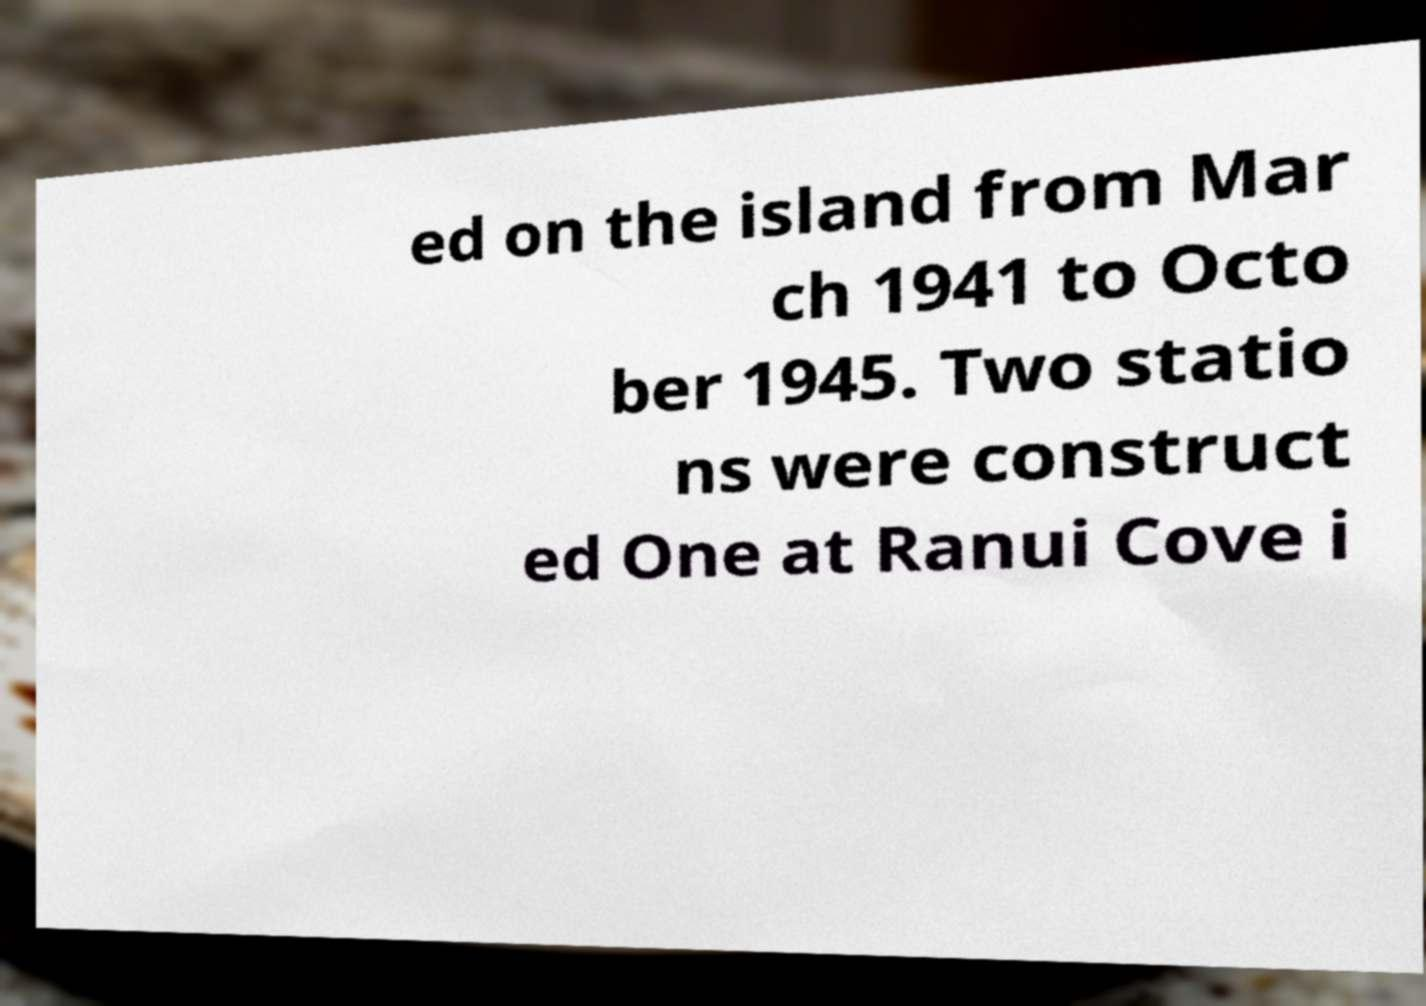For documentation purposes, I need the text within this image transcribed. Could you provide that? ed on the island from Mar ch 1941 to Octo ber 1945. Two statio ns were construct ed One at Ranui Cove i 